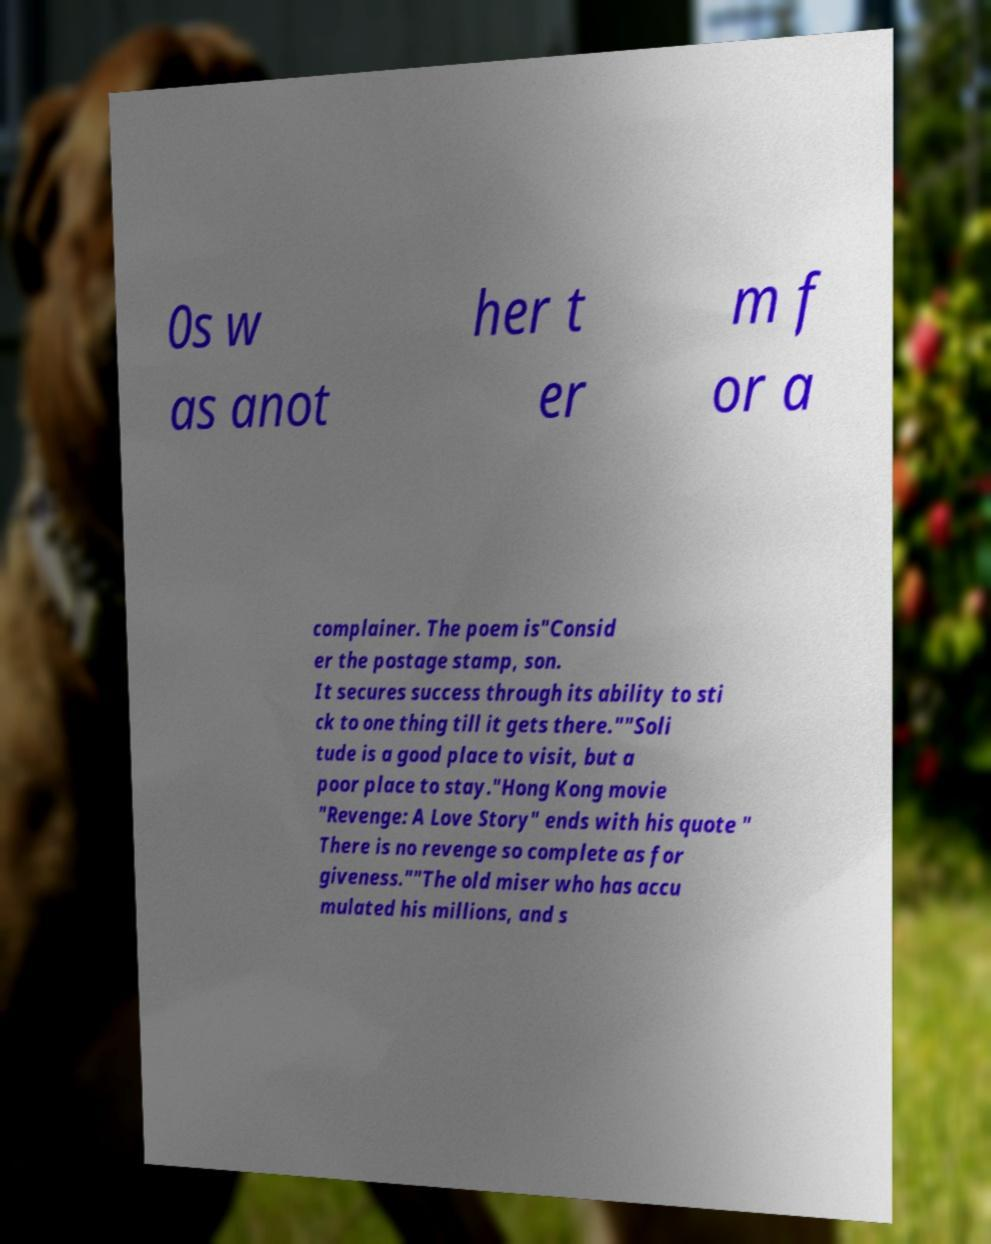Can you accurately transcribe the text from the provided image for me? 0s w as anot her t er m f or a complainer. The poem is"Consid er the postage stamp, son. It secures success through its ability to sti ck to one thing till it gets there.""Soli tude is a good place to visit, but a poor place to stay."Hong Kong movie "Revenge: A Love Story" ends with his quote " There is no revenge so complete as for giveness.""The old miser who has accu mulated his millions, and s 